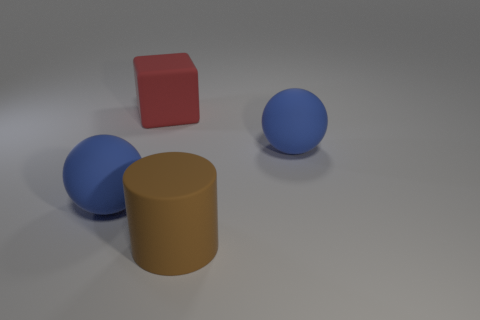Add 3 matte blocks. How many objects exist? 7 Subtract all cubes. How many objects are left? 3 Add 3 red blocks. How many red blocks exist? 4 Subtract 1 brown cylinders. How many objects are left? 3 Subtract all blue shiny objects. Subtract all matte blocks. How many objects are left? 3 Add 1 rubber blocks. How many rubber blocks are left? 2 